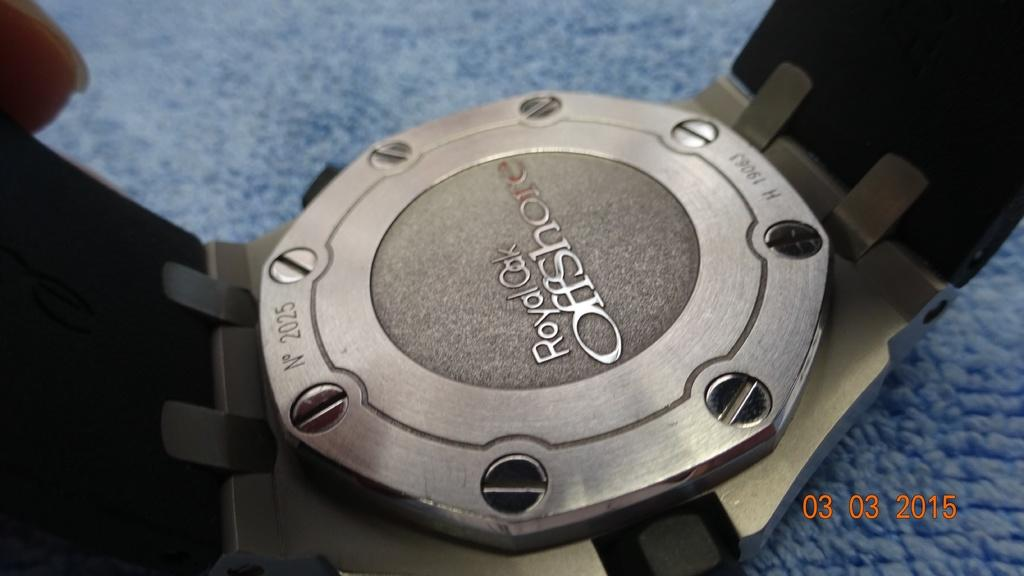Provide a one-sentence caption for the provided image. A metal plate ringed with screws bears the stamp Royal Oak Offshore. 